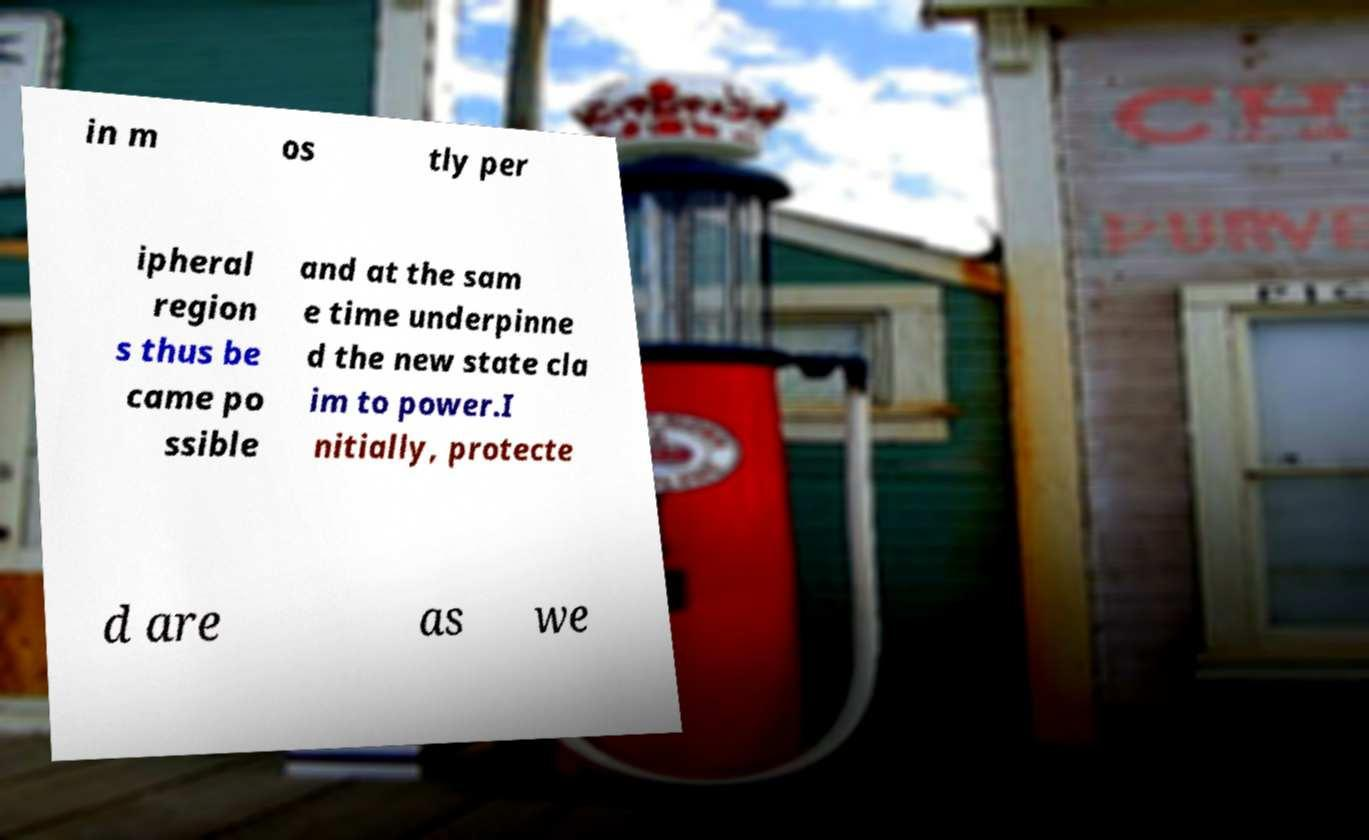Could you assist in decoding the text presented in this image and type it out clearly? in m os tly per ipheral region s thus be came po ssible and at the sam e time underpinne d the new state cla im to power.I nitially, protecte d are as we 